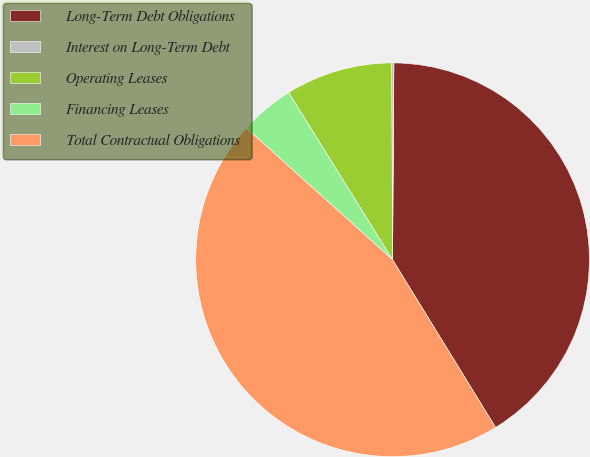Convert chart to OTSL. <chart><loc_0><loc_0><loc_500><loc_500><pie_chart><fcel>Long-Term Debt Obligations<fcel>Interest on Long-Term Debt<fcel>Operating Leases<fcel>Financing Leases<fcel>Total Contractual Obligations<nl><fcel>41.13%<fcel>0.18%<fcel>8.78%<fcel>4.48%<fcel>45.43%<nl></chart> 